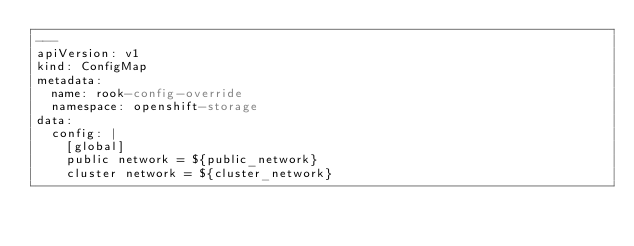Convert code to text. <code><loc_0><loc_0><loc_500><loc_500><_YAML_>---
apiVersion: v1
kind: ConfigMap
metadata:
  name: rook-config-override
  namespace: openshift-storage
data:
  config: |
    [global]
    public network = ${public_network}
    cluster network = ${cluster_network}
</code> 